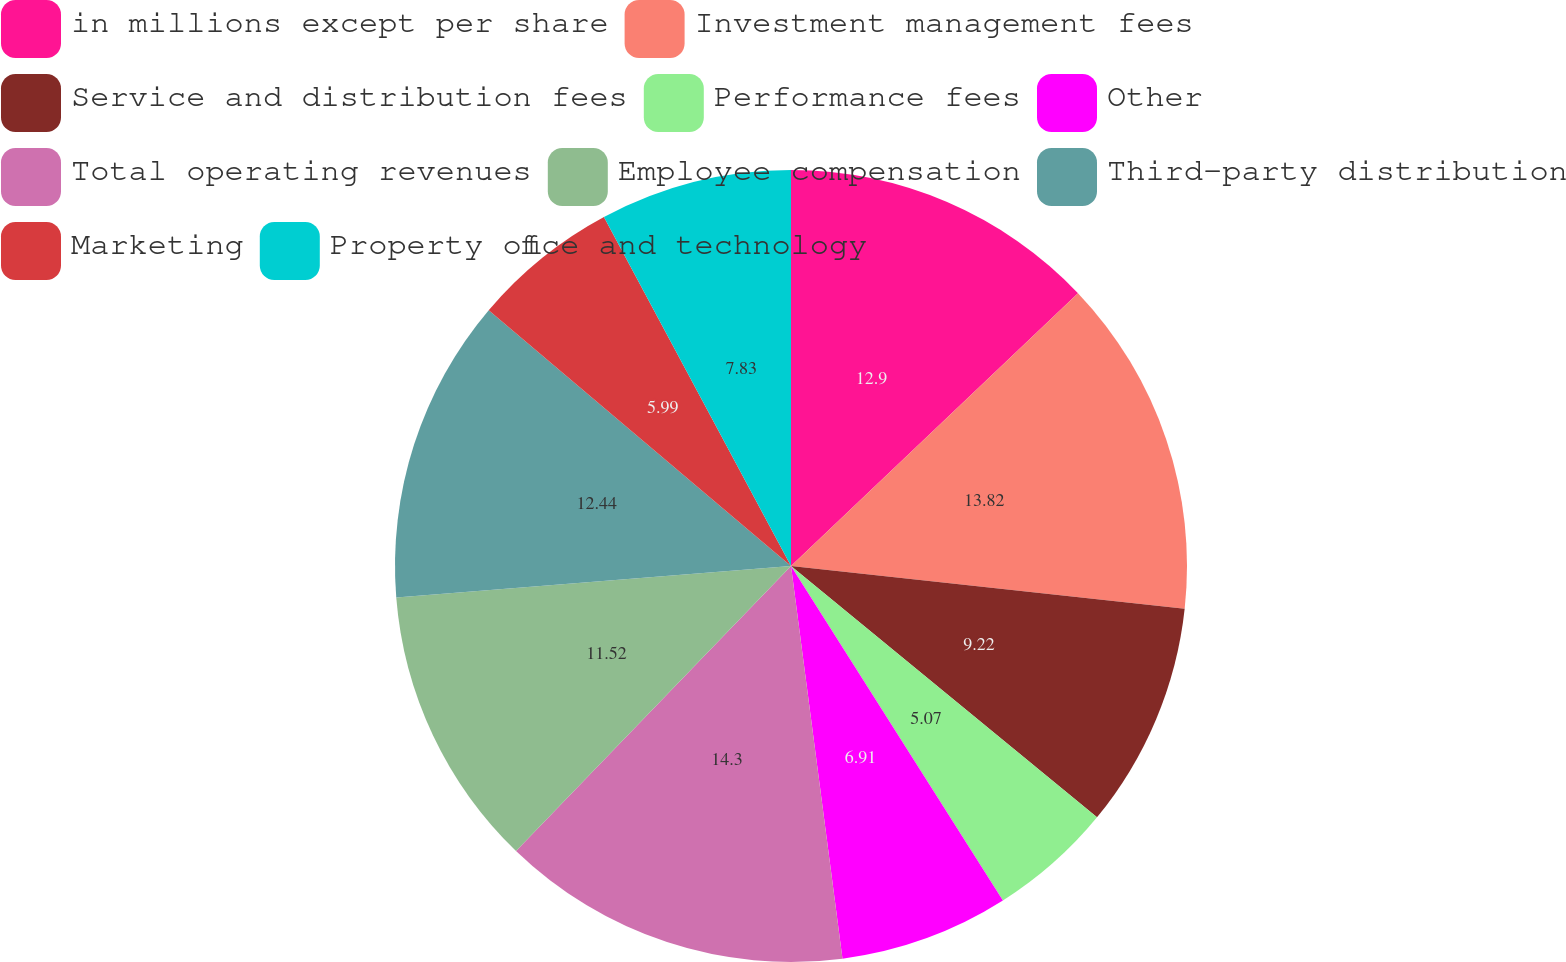Convert chart to OTSL. <chart><loc_0><loc_0><loc_500><loc_500><pie_chart><fcel>in millions except per share<fcel>Investment management fees<fcel>Service and distribution fees<fcel>Performance fees<fcel>Other<fcel>Total operating revenues<fcel>Employee compensation<fcel>Third-party distribution<fcel>Marketing<fcel>Property office and technology<nl><fcel>12.9%<fcel>13.82%<fcel>9.22%<fcel>5.07%<fcel>6.91%<fcel>14.29%<fcel>11.52%<fcel>12.44%<fcel>5.99%<fcel>7.83%<nl></chart> 